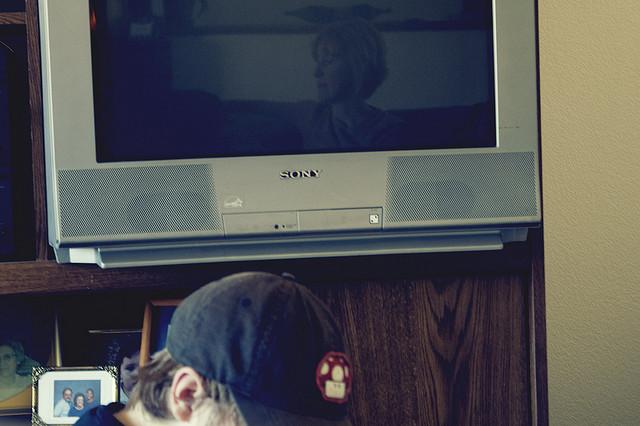How many people are in the picture in the background?
Be succinct. 1. What is the man doing?
Give a very brief answer. Reading. What brand of TV is shown?
Give a very brief answer. Sony. What brand is the monitor?
Be succinct. Sony. Is the TV on?
Short answer required. No. What is in the small frames on the wall?
Short answer required. Pictures. Is there a cat?
Keep it brief. No. What kind of TV is shown?
Concise answer only. Sony. Is this an HDTV?
Give a very brief answer. No. Is the television set turned on or off?
Write a very short answer. Off. What is in the reflection?
Quick response, please. Woman. Is the television on?
Quick response, please. No. Is there a woman on TV?
Quick response, please. Yes. Is the TV off?
Give a very brief answer. Yes. Figure out what the sign say based on the partial letters visible?
Concise answer only. Sony. Is the tv on?
Concise answer only. No. 